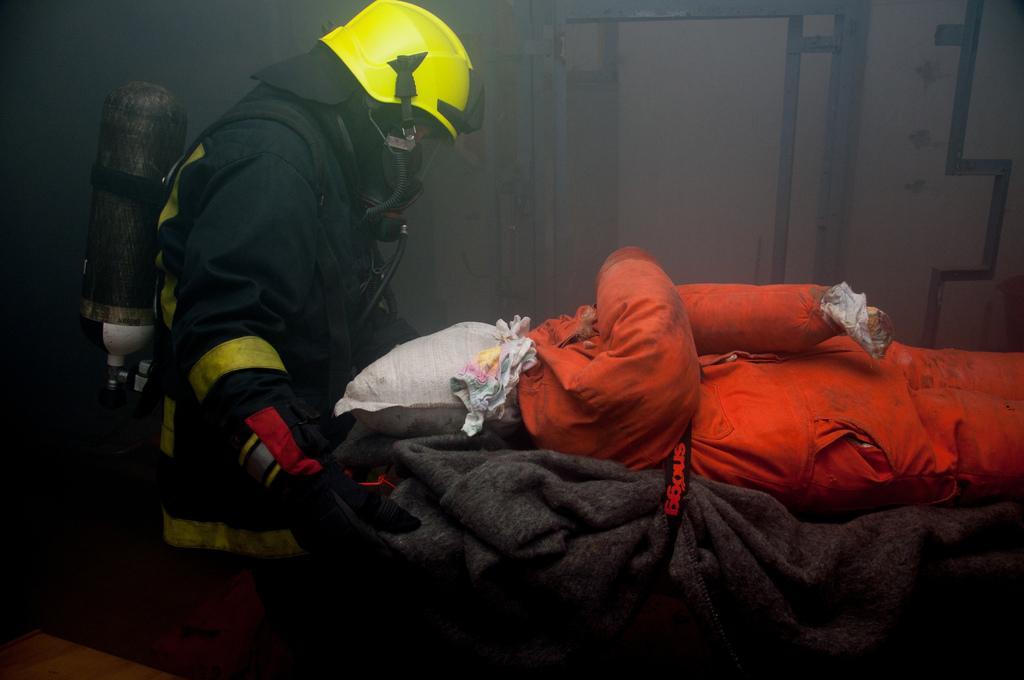Can you describe this image briefly? This is an inside view. Here I can see a person wearing a costume, helmet on the head and sitting facing towards the right side. In front of him there is a doll dressed in a costume. In the background there is a wall and I can see few poles. 